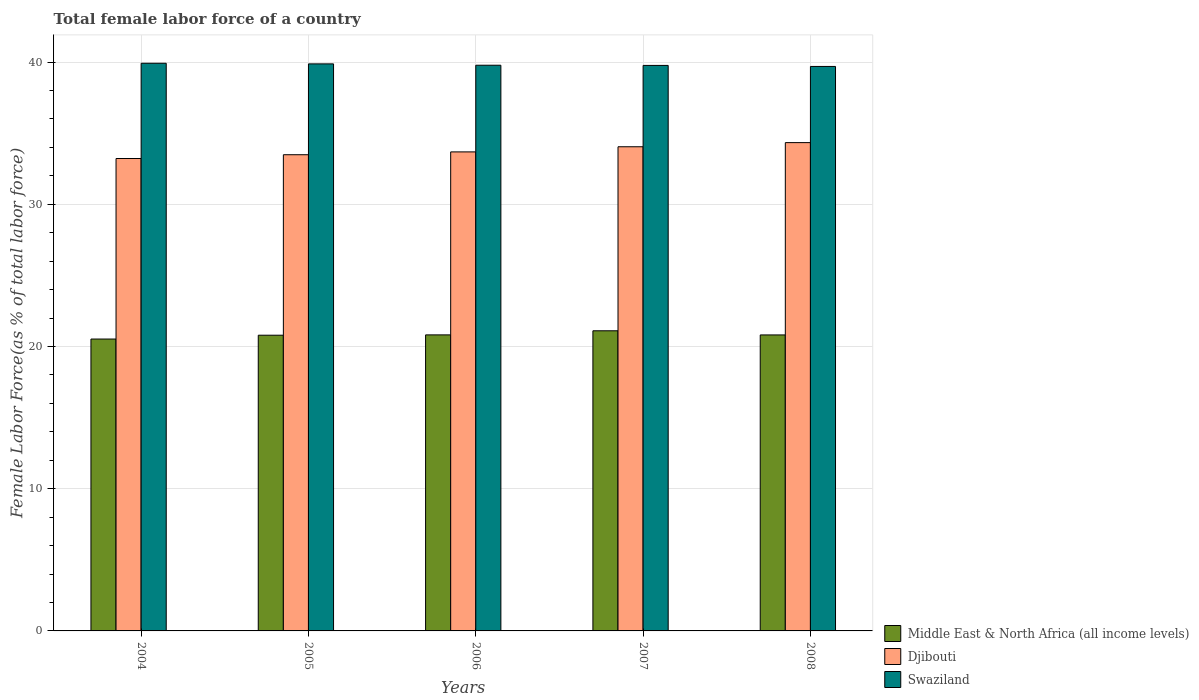How many different coloured bars are there?
Keep it short and to the point. 3. Are the number of bars on each tick of the X-axis equal?
Give a very brief answer. Yes. What is the label of the 5th group of bars from the left?
Provide a succinct answer. 2008. In how many cases, is the number of bars for a given year not equal to the number of legend labels?
Provide a succinct answer. 0. What is the percentage of female labor force in Swaziland in 2006?
Offer a very short reply. 39.78. Across all years, what is the maximum percentage of female labor force in Middle East & North Africa (all income levels)?
Your answer should be compact. 21.11. Across all years, what is the minimum percentage of female labor force in Swaziland?
Make the answer very short. 39.7. In which year was the percentage of female labor force in Middle East & North Africa (all income levels) maximum?
Provide a succinct answer. 2007. In which year was the percentage of female labor force in Swaziland minimum?
Provide a succinct answer. 2008. What is the total percentage of female labor force in Middle East & North Africa (all income levels) in the graph?
Offer a terse response. 104.06. What is the difference between the percentage of female labor force in Djibouti in 2005 and that in 2007?
Offer a very short reply. -0.56. What is the difference between the percentage of female labor force in Djibouti in 2008 and the percentage of female labor force in Swaziland in 2004?
Ensure brevity in your answer.  -5.58. What is the average percentage of female labor force in Middle East & North Africa (all income levels) per year?
Keep it short and to the point. 20.81. In the year 2007, what is the difference between the percentage of female labor force in Swaziland and percentage of female labor force in Middle East & North Africa (all income levels)?
Provide a succinct answer. 18.66. In how many years, is the percentage of female labor force in Djibouti greater than 4 %?
Offer a very short reply. 5. What is the ratio of the percentage of female labor force in Swaziland in 2007 to that in 2008?
Ensure brevity in your answer.  1. What is the difference between the highest and the second highest percentage of female labor force in Middle East & North Africa (all income levels)?
Make the answer very short. 0.29. What is the difference between the highest and the lowest percentage of female labor force in Djibouti?
Offer a terse response. 1.12. Is the sum of the percentage of female labor force in Djibouti in 2005 and 2006 greater than the maximum percentage of female labor force in Swaziland across all years?
Ensure brevity in your answer.  Yes. What does the 1st bar from the left in 2008 represents?
Provide a succinct answer. Middle East & North Africa (all income levels). What does the 2nd bar from the right in 2004 represents?
Provide a succinct answer. Djibouti. Is it the case that in every year, the sum of the percentage of female labor force in Djibouti and percentage of female labor force in Swaziland is greater than the percentage of female labor force in Middle East & North Africa (all income levels)?
Your response must be concise. Yes. How many years are there in the graph?
Provide a short and direct response. 5. What is the difference between two consecutive major ticks on the Y-axis?
Your answer should be very brief. 10. Does the graph contain any zero values?
Provide a short and direct response. No. Does the graph contain grids?
Your answer should be very brief. Yes. How many legend labels are there?
Keep it short and to the point. 3. What is the title of the graph?
Make the answer very short. Total female labor force of a country. Does "Iceland" appear as one of the legend labels in the graph?
Your answer should be very brief. No. What is the label or title of the Y-axis?
Your response must be concise. Female Labor Force(as % of total labor force). What is the Female Labor Force(as % of total labor force) of Middle East & North Africa (all income levels) in 2004?
Offer a terse response. 20.53. What is the Female Labor Force(as % of total labor force) of Djibouti in 2004?
Your response must be concise. 33.22. What is the Female Labor Force(as % of total labor force) in Swaziland in 2004?
Ensure brevity in your answer.  39.92. What is the Female Labor Force(as % of total labor force) of Middle East & North Africa (all income levels) in 2005?
Make the answer very short. 20.8. What is the Female Labor Force(as % of total labor force) of Djibouti in 2005?
Ensure brevity in your answer.  33.49. What is the Female Labor Force(as % of total labor force) of Swaziland in 2005?
Provide a short and direct response. 39.88. What is the Female Labor Force(as % of total labor force) of Middle East & North Africa (all income levels) in 2006?
Offer a very short reply. 20.82. What is the Female Labor Force(as % of total labor force) of Djibouti in 2006?
Offer a terse response. 33.69. What is the Female Labor Force(as % of total labor force) in Swaziland in 2006?
Your response must be concise. 39.78. What is the Female Labor Force(as % of total labor force) in Middle East & North Africa (all income levels) in 2007?
Ensure brevity in your answer.  21.11. What is the Female Labor Force(as % of total labor force) in Djibouti in 2007?
Offer a terse response. 34.05. What is the Female Labor Force(as % of total labor force) in Swaziland in 2007?
Offer a terse response. 39.77. What is the Female Labor Force(as % of total labor force) of Middle East & North Africa (all income levels) in 2008?
Give a very brief answer. 20.81. What is the Female Labor Force(as % of total labor force) of Djibouti in 2008?
Offer a very short reply. 34.34. What is the Female Labor Force(as % of total labor force) in Swaziland in 2008?
Keep it short and to the point. 39.7. Across all years, what is the maximum Female Labor Force(as % of total labor force) in Middle East & North Africa (all income levels)?
Your answer should be very brief. 21.11. Across all years, what is the maximum Female Labor Force(as % of total labor force) in Djibouti?
Make the answer very short. 34.34. Across all years, what is the maximum Female Labor Force(as % of total labor force) in Swaziland?
Provide a short and direct response. 39.92. Across all years, what is the minimum Female Labor Force(as % of total labor force) in Middle East & North Africa (all income levels)?
Offer a terse response. 20.53. Across all years, what is the minimum Female Labor Force(as % of total labor force) of Djibouti?
Provide a short and direct response. 33.22. Across all years, what is the minimum Female Labor Force(as % of total labor force) in Swaziland?
Make the answer very short. 39.7. What is the total Female Labor Force(as % of total labor force) in Middle East & North Africa (all income levels) in the graph?
Offer a terse response. 104.06. What is the total Female Labor Force(as % of total labor force) of Djibouti in the graph?
Ensure brevity in your answer.  168.78. What is the total Female Labor Force(as % of total labor force) of Swaziland in the graph?
Give a very brief answer. 199.04. What is the difference between the Female Labor Force(as % of total labor force) in Middle East & North Africa (all income levels) in 2004 and that in 2005?
Offer a terse response. -0.27. What is the difference between the Female Labor Force(as % of total labor force) of Djibouti in 2004 and that in 2005?
Your response must be concise. -0.27. What is the difference between the Female Labor Force(as % of total labor force) in Swaziland in 2004 and that in 2005?
Offer a very short reply. 0.04. What is the difference between the Female Labor Force(as % of total labor force) in Middle East & North Africa (all income levels) in 2004 and that in 2006?
Offer a terse response. -0.29. What is the difference between the Female Labor Force(as % of total labor force) of Djibouti in 2004 and that in 2006?
Ensure brevity in your answer.  -0.46. What is the difference between the Female Labor Force(as % of total labor force) of Swaziland in 2004 and that in 2006?
Provide a short and direct response. 0.14. What is the difference between the Female Labor Force(as % of total labor force) in Middle East & North Africa (all income levels) in 2004 and that in 2007?
Your answer should be compact. -0.58. What is the difference between the Female Labor Force(as % of total labor force) of Djibouti in 2004 and that in 2007?
Your answer should be very brief. -0.83. What is the difference between the Female Labor Force(as % of total labor force) of Swaziland in 2004 and that in 2007?
Your response must be concise. 0.15. What is the difference between the Female Labor Force(as % of total labor force) of Middle East & North Africa (all income levels) in 2004 and that in 2008?
Make the answer very short. -0.29. What is the difference between the Female Labor Force(as % of total labor force) in Djibouti in 2004 and that in 2008?
Offer a terse response. -1.12. What is the difference between the Female Labor Force(as % of total labor force) in Swaziland in 2004 and that in 2008?
Your answer should be very brief. 0.22. What is the difference between the Female Labor Force(as % of total labor force) in Middle East & North Africa (all income levels) in 2005 and that in 2006?
Offer a very short reply. -0.02. What is the difference between the Female Labor Force(as % of total labor force) of Djibouti in 2005 and that in 2006?
Your answer should be very brief. -0.2. What is the difference between the Female Labor Force(as % of total labor force) of Swaziland in 2005 and that in 2006?
Provide a short and direct response. 0.09. What is the difference between the Female Labor Force(as % of total labor force) in Middle East & North Africa (all income levels) in 2005 and that in 2007?
Ensure brevity in your answer.  -0.31. What is the difference between the Female Labor Force(as % of total labor force) of Djibouti in 2005 and that in 2007?
Offer a very short reply. -0.56. What is the difference between the Female Labor Force(as % of total labor force) in Swaziland in 2005 and that in 2007?
Keep it short and to the point. 0.11. What is the difference between the Female Labor Force(as % of total labor force) of Middle East & North Africa (all income levels) in 2005 and that in 2008?
Make the answer very short. -0.02. What is the difference between the Female Labor Force(as % of total labor force) of Djibouti in 2005 and that in 2008?
Keep it short and to the point. -0.85. What is the difference between the Female Labor Force(as % of total labor force) of Swaziland in 2005 and that in 2008?
Give a very brief answer. 0.18. What is the difference between the Female Labor Force(as % of total labor force) in Middle East & North Africa (all income levels) in 2006 and that in 2007?
Give a very brief answer. -0.29. What is the difference between the Female Labor Force(as % of total labor force) in Djibouti in 2006 and that in 2007?
Give a very brief answer. -0.36. What is the difference between the Female Labor Force(as % of total labor force) in Swaziland in 2006 and that in 2007?
Provide a short and direct response. 0.01. What is the difference between the Female Labor Force(as % of total labor force) in Middle East & North Africa (all income levels) in 2006 and that in 2008?
Your answer should be very brief. 0. What is the difference between the Female Labor Force(as % of total labor force) of Djibouti in 2006 and that in 2008?
Give a very brief answer. -0.65. What is the difference between the Female Labor Force(as % of total labor force) in Swaziland in 2006 and that in 2008?
Make the answer very short. 0.09. What is the difference between the Female Labor Force(as % of total labor force) in Middle East & North Africa (all income levels) in 2007 and that in 2008?
Offer a terse response. 0.29. What is the difference between the Female Labor Force(as % of total labor force) of Djibouti in 2007 and that in 2008?
Provide a short and direct response. -0.29. What is the difference between the Female Labor Force(as % of total labor force) of Swaziland in 2007 and that in 2008?
Provide a short and direct response. 0.07. What is the difference between the Female Labor Force(as % of total labor force) in Middle East & North Africa (all income levels) in 2004 and the Female Labor Force(as % of total labor force) in Djibouti in 2005?
Ensure brevity in your answer.  -12.96. What is the difference between the Female Labor Force(as % of total labor force) in Middle East & North Africa (all income levels) in 2004 and the Female Labor Force(as % of total labor force) in Swaziland in 2005?
Give a very brief answer. -19.35. What is the difference between the Female Labor Force(as % of total labor force) in Djibouti in 2004 and the Female Labor Force(as % of total labor force) in Swaziland in 2005?
Your answer should be very brief. -6.65. What is the difference between the Female Labor Force(as % of total labor force) in Middle East & North Africa (all income levels) in 2004 and the Female Labor Force(as % of total labor force) in Djibouti in 2006?
Your response must be concise. -13.16. What is the difference between the Female Labor Force(as % of total labor force) of Middle East & North Africa (all income levels) in 2004 and the Female Labor Force(as % of total labor force) of Swaziland in 2006?
Give a very brief answer. -19.26. What is the difference between the Female Labor Force(as % of total labor force) of Djibouti in 2004 and the Female Labor Force(as % of total labor force) of Swaziland in 2006?
Make the answer very short. -6.56. What is the difference between the Female Labor Force(as % of total labor force) in Middle East & North Africa (all income levels) in 2004 and the Female Labor Force(as % of total labor force) in Djibouti in 2007?
Give a very brief answer. -13.52. What is the difference between the Female Labor Force(as % of total labor force) in Middle East & North Africa (all income levels) in 2004 and the Female Labor Force(as % of total labor force) in Swaziland in 2007?
Ensure brevity in your answer.  -19.24. What is the difference between the Female Labor Force(as % of total labor force) in Djibouti in 2004 and the Female Labor Force(as % of total labor force) in Swaziland in 2007?
Make the answer very short. -6.55. What is the difference between the Female Labor Force(as % of total labor force) in Middle East & North Africa (all income levels) in 2004 and the Female Labor Force(as % of total labor force) in Djibouti in 2008?
Offer a very short reply. -13.81. What is the difference between the Female Labor Force(as % of total labor force) in Middle East & North Africa (all income levels) in 2004 and the Female Labor Force(as % of total labor force) in Swaziland in 2008?
Make the answer very short. -19.17. What is the difference between the Female Labor Force(as % of total labor force) of Djibouti in 2004 and the Female Labor Force(as % of total labor force) of Swaziland in 2008?
Provide a short and direct response. -6.47. What is the difference between the Female Labor Force(as % of total labor force) in Middle East & North Africa (all income levels) in 2005 and the Female Labor Force(as % of total labor force) in Djibouti in 2006?
Provide a succinct answer. -12.89. What is the difference between the Female Labor Force(as % of total labor force) of Middle East & North Africa (all income levels) in 2005 and the Female Labor Force(as % of total labor force) of Swaziland in 2006?
Provide a succinct answer. -18.99. What is the difference between the Female Labor Force(as % of total labor force) of Djibouti in 2005 and the Female Labor Force(as % of total labor force) of Swaziland in 2006?
Give a very brief answer. -6.29. What is the difference between the Female Labor Force(as % of total labor force) of Middle East & North Africa (all income levels) in 2005 and the Female Labor Force(as % of total labor force) of Djibouti in 2007?
Your answer should be very brief. -13.25. What is the difference between the Female Labor Force(as % of total labor force) in Middle East & North Africa (all income levels) in 2005 and the Female Labor Force(as % of total labor force) in Swaziland in 2007?
Give a very brief answer. -18.97. What is the difference between the Female Labor Force(as % of total labor force) in Djibouti in 2005 and the Female Labor Force(as % of total labor force) in Swaziland in 2007?
Provide a succinct answer. -6.28. What is the difference between the Female Labor Force(as % of total labor force) of Middle East & North Africa (all income levels) in 2005 and the Female Labor Force(as % of total labor force) of Djibouti in 2008?
Offer a terse response. -13.54. What is the difference between the Female Labor Force(as % of total labor force) of Middle East & North Africa (all income levels) in 2005 and the Female Labor Force(as % of total labor force) of Swaziland in 2008?
Give a very brief answer. -18.9. What is the difference between the Female Labor Force(as % of total labor force) in Djibouti in 2005 and the Female Labor Force(as % of total labor force) in Swaziland in 2008?
Give a very brief answer. -6.21. What is the difference between the Female Labor Force(as % of total labor force) in Middle East & North Africa (all income levels) in 2006 and the Female Labor Force(as % of total labor force) in Djibouti in 2007?
Your answer should be compact. -13.23. What is the difference between the Female Labor Force(as % of total labor force) of Middle East & North Africa (all income levels) in 2006 and the Female Labor Force(as % of total labor force) of Swaziland in 2007?
Keep it short and to the point. -18.95. What is the difference between the Female Labor Force(as % of total labor force) of Djibouti in 2006 and the Female Labor Force(as % of total labor force) of Swaziland in 2007?
Ensure brevity in your answer.  -6.08. What is the difference between the Female Labor Force(as % of total labor force) of Middle East & North Africa (all income levels) in 2006 and the Female Labor Force(as % of total labor force) of Djibouti in 2008?
Offer a very short reply. -13.52. What is the difference between the Female Labor Force(as % of total labor force) of Middle East & North Africa (all income levels) in 2006 and the Female Labor Force(as % of total labor force) of Swaziland in 2008?
Make the answer very short. -18.88. What is the difference between the Female Labor Force(as % of total labor force) of Djibouti in 2006 and the Female Labor Force(as % of total labor force) of Swaziland in 2008?
Give a very brief answer. -6.01. What is the difference between the Female Labor Force(as % of total labor force) in Middle East & North Africa (all income levels) in 2007 and the Female Labor Force(as % of total labor force) in Djibouti in 2008?
Your answer should be very brief. -13.23. What is the difference between the Female Labor Force(as % of total labor force) of Middle East & North Africa (all income levels) in 2007 and the Female Labor Force(as % of total labor force) of Swaziland in 2008?
Keep it short and to the point. -18.59. What is the difference between the Female Labor Force(as % of total labor force) in Djibouti in 2007 and the Female Labor Force(as % of total labor force) in Swaziland in 2008?
Your response must be concise. -5.65. What is the average Female Labor Force(as % of total labor force) in Middle East & North Africa (all income levels) per year?
Your answer should be very brief. 20.81. What is the average Female Labor Force(as % of total labor force) of Djibouti per year?
Give a very brief answer. 33.76. What is the average Female Labor Force(as % of total labor force) in Swaziland per year?
Provide a short and direct response. 39.81. In the year 2004, what is the difference between the Female Labor Force(as % of total labor force) in Middle East & North Africa (all income levels) and Female Labor Force(as % of total labor force) in Djibouti?
Offer a very short reply. -12.7. In the year 2004, what is the difference between the Female Labor Force(as % of total labor force) in Middle East & North Africa (all income levels) and Female Labor Force(as % of total labor force) in Swaziland?
Provide a succinct answer. -19.39. In the year 2004, what is the difference between the Female Labor Force(as % of total labor force) in Djibouti and Female Labor Force(as % of total labor force) in Swaziland?
Ensure brevity in your answer.  -6.7. In the year 2005, what is the difference between the Female Labor Force(as % of total labor force) in Middle East & North Africa (all income levels) and Female Labor Force(as % of total labor force) in Djibouti?
Your answer should be compact. -12.69. In the year 2005, what is the difference between the Female Labor Force(as % of total labor force) in Middle East & North Africa (all income levels) and Female Labor Force(as % of total labor force) in Swaziland?
Offer a terse response. -19.08. In the year 2005, what is the difference between the Female Labor Force(as % of total labor force) of Djibouti and Female Labor Force(as % of total labor force) of Swaziland?
Keep it short and to the point. -6.39. In the year 2006, what is the difference between the Female Labor Force(as % of total labor force) of Middle East & North Africa (all income levels) and Female Labor Force(as % of total labor force) of Djibouti?
Your answer should be compact. -12.87. In the year 2006, what is the difference between the Female Labor Force(as % of total labor force) of Middle East & North Africa (all income levels) and Female Labor Force(as % of total labor force) of Swaziland?
Your answer should be compact. -18.96. In the year 2006, what is the difference between the Female Labor Force(as % of total labor force) of Djibouti and Female Labor Force(as % of total labor force) of Swaziland?
Ensure brevity in your answer.  -6.1. In the year 2007, what is the difference between the Female Labor Force(as % of total labor force) in Middle East & North Africa (all income levels) and Female Labor Force(as % of total labor force) in Djibouti?
Keep it short and to the point. -12.94. In the year 2007, what is the difference between the Female Labor Force(as % of total labor force) in Middle East & North Africa (all income levels) and Female Labor Force(as % of total labor force) in Swaziland?
Offer a very short reply. -18.66. In the year 2007, what is the difference between the Female Labor Force(as % of total labor force) of Djibouti and Female Labor Force(as % of total labor force) of Swaziland?
Give a very brief answer. -5.72. In the year 2008, what is the difference between the Female Labor Force(as % of total labor force) of Middle East & North Africa (all income levels) and Female Labor Force(as % of total labor force) of Djibouti?
Provide a short and direct response. -13.52. In the year 2008, what is the difference between the Female Labor Force(as % of total labor force) in Middle East & North Africa (all income levels) and Female Labor Force(as % of total labor force) in Swaziland?
Your response must be concise. -18.88. In the year 2008, what is the difference between the Female Labor Force(as % of total labor force) of Djibouti and Female Labor Force(as % of total labor force) of Swaziland?
Provide a short and direct response. -5.36. What is the ratio of the Female Labor Force(as % of total labor force) of Djibouti in 2004 to that in 2005?
Your answer should be compact. 0.99. What is the ratio of the Female Labor Force(as % of total labor force) in Middle East & North Africa (all income levels) in 2004 to that in 2006?
Provide a succinct answer. 0.99. What is the ratio of the Female Labor Force(as % of total labor force) of Djibouti in 2004 to that in 2006?
Offer a very short reply. 0.99. What is the ratio of the Female Labor Force(as % of total labor force) in Swaziland in 2004 to that in 2006?
Keep it short and to the point. 1. What is the ratio of the Female Labor Force(as % of total labor force) in Middle East & North Africa (all income levels) in 2004 to that in 2007?
Give a very brief answer. 0.97. What is the ratio of the Female Labor Force(as % of total labor force) in Djibouti in 2004 to that in 2007?
Your response must be concise. 0.98. What is the ratio of the Female Labor Force(as % of total labor force) in Swaziland in 2004 to that in 2007?
Offer a terse response. 1. What is the ratio of the Female Labor Force(as % of total labor force) in Middle East & North Africa (all income levels) in 2004 to that in 2008?
Make the answer very short. 0.99. What is the ratio of the Female Labor Force(as % of total labor force) of Djibouti in 2004 to that in 2008?
Keep it short and to the point. 0.97. What is the ratio of the Female Labor Force(as % of total labor force) in Swaziland in 2004 to that in 2008?
Make the answer very short. 1.01. What is the ratio of the Female Labor Force(as % of total labor force) in Djibouti in 2005 to that in 2006?
Offer a very short reply. 0.99. What is the ratio of the Female Labor Force(as % of total labor force) in Swaziland in 2005 to that in 2006?
Offer a terse response. 1. What is the ratio of the Female Labor Force(as % of total labor force) in Middle East & North Africa (all income levels) in 2005 to that in 2007?
Provide a short and direct response. 0.99. What is the ratio of the Female Labor Force(as % of total labor force) in Djibouti in 2005 to that in 2007?
Offer a terse response. 0.98. What is the ratio of the Female Labor Force(as % of total labor force) in Middle East & North Africa (all income levels) in 2005 to that in 2008?
Provide a succinct answer. 1. What is the ratio of the Female Labor Force(as % of total labor force) in Djibouti in 2005 to that in 2008?
Keep it short and to the point. 0.98. What is the ratio of the Female Labor Force(as % of total labor force) of Middle East & North Africa (all income levels) in 2006 to that in 2007?
Offer a very short reply. 0.99. What is the ratio of the Female Labor Force(as % of total labor force) in Djibouti in 2006 to that in 2007?
Your answer should be compact. 0.99. What is the ratio of the Female Labor Force(as % of total labor force) in Djibouti in 2006 to that in 2008?
Your response must be concise. 0.98. What is the ratio of the Female Labor Force(as % of total labor force) of Swaziland in 2006 to that in 2008?
Give a very brief answer. 1. What is the difference between the highest and the second highest Female Labor Force(as % of total labor force) of Middle East & North Africa (all income levels)?
Keep it short and to the point. 0.29. What is the difference between the highest and the second highest Female Labor Force(as % of total labor force) in Djibouti?
Give a very brief answer. 0.29. What is the difference between the highest and the second highest Female Labor Force(as % of total labor force) in Swaziland?
Your response must be concise. 0.04. What is the difference between the highest and the lowest Female Labor Force(as % of total labor force) of Middle East & North Africa (all income levels)?
Make the answer very short. 0.58. What is the difference between the highest and the lowest Female Labor Force(as % of total labor force) in Djibouti?
Your response must be concise. 1.12. What is the difference between the highest and the lowest Female Labor Force(as % of total labor force) in Swaziland?
Offer a very short reply. 0.22. 